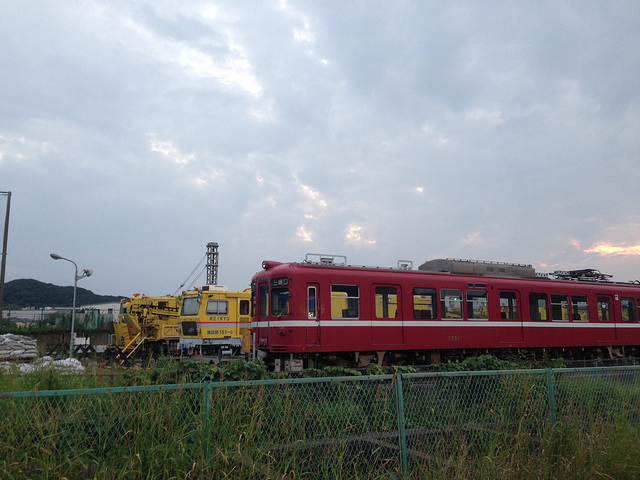<image>What is the name of the train? I don't know the name of the train. It could be 'subway', 'santa fe', 'transit', 'carriage' or 'thomas'. What color is the letter on the train? It is ambiguous what color the letter on the train is. Possible colors are black, red, grey, or white. Who manufactured this train car? It is unknown who manufactured this train car. It might be union pacific or caterpillar. How many train cars are in the picture? I don't know. The number of train cars can be 1, 2, or 3. What color is the chain? It is ambiguous what color the chain is. It can be green, silver, red, black, or gray. What color is the letter on the train? It is ambiguous what color the letter on the train is. It can be seen in black, red, gray, white or no letter at all. What is the name of the train? The name of the train is unknown. It can be seen as 'subway', 'red', 'santa fe', 'unknown', 'not sure', "can't tell", 'transit', 'carriage' or 'thomas'. Who manufactured this train car? I am not sure who manufactured this train car. How many train cars are in the picture? I don't know how many train cars are in the picture. It can be 1, 2, or 3. What color is the chain? It is unclear what color the chain is. It could be green, silver, red, black, or gray. 